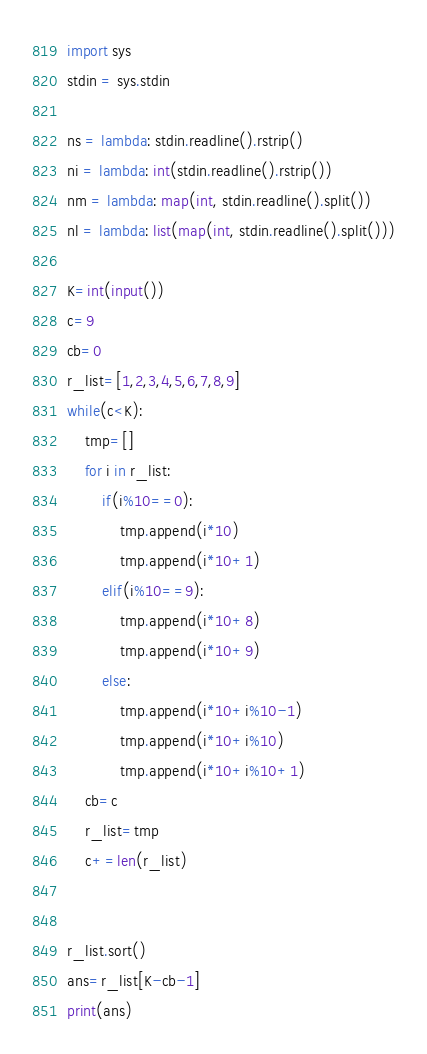Convert code to text. <code><loc_0><loc_0><loc_500><loc_500><_Python_>import sys
stdin = sys.stdin

ns = lambda: stdin.readline().rstrip()
ni = lambda: int(stdin.readline().rstrip())
nm = lambda: map(int, stdin.readline().split())
nl = lambda: list(map(int, stdin.readline().split()))

K=int(input())
c=9
cb=0
r_list=[1,2,3,4,5,6,7,8,9]
while(c<K):
    tmp=[]
    for i in r_list:
        if(i%10==0):
            tmp.append(i*10)
            tmp.append(i*10+1)
        elif(i%10==9):
            tmp.append(i*10+8)
            tmp.append(i*10+9)
        else:
            tmp.append(i*10+i%10-1)
            tmp.append(i*10+i%10)
            tmp.append(i*10+i%10+1)
    cb=c
    r_list=tmp
    c+=len(r_list)

    
r_list.sort()
ans=r_list[K-cb-1]
print(ans)
</code> 